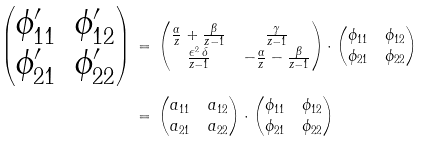<formula> <loc_0><loc_0><loc_500><loc_500>\begin{pmatrix} \phi _ { 1 1 } ^ { \prime } & \phi _ { 1 2 } ^ { \prime } \\ \phi _ { 2 1 } ^ { \prime } & \phi _ { 2 2 } ^ { \prime } \end{pmatrix} \, & = \, \begin{pmatrix} \frac { \alpha } { z } + \frac { \beta } { z - 1 } & \frac { \gamma } { z - 1 } \\ \frac { \epsilon ^ { 2 } \, \delta } { z - 1 } & - \frac { \alpha } { z } - \frac { \beta } { z - 1 } \end{pmatrix} \cdot \begin{pmatrix} \phi _ { 1 1 } & \phi _ { 1 2 } \\ \phi _ { 2 1 } & \phi _ { 2 2 } \end{pmatrix} \, \\ & = \, \begin{pmatrix} a _ { 1 1 } & a _ { 1 2 } \\ a _ { 2 1 } & a _ { 2 2 } \end{pmatrix} \cdot \begin{pmatrix} \phi _ { 1 1 } & \phi _ { 1 2 } \\ \phi _ { 2 1 } & \phi _ { 2 2 } \end{pmatrix}</formula> 